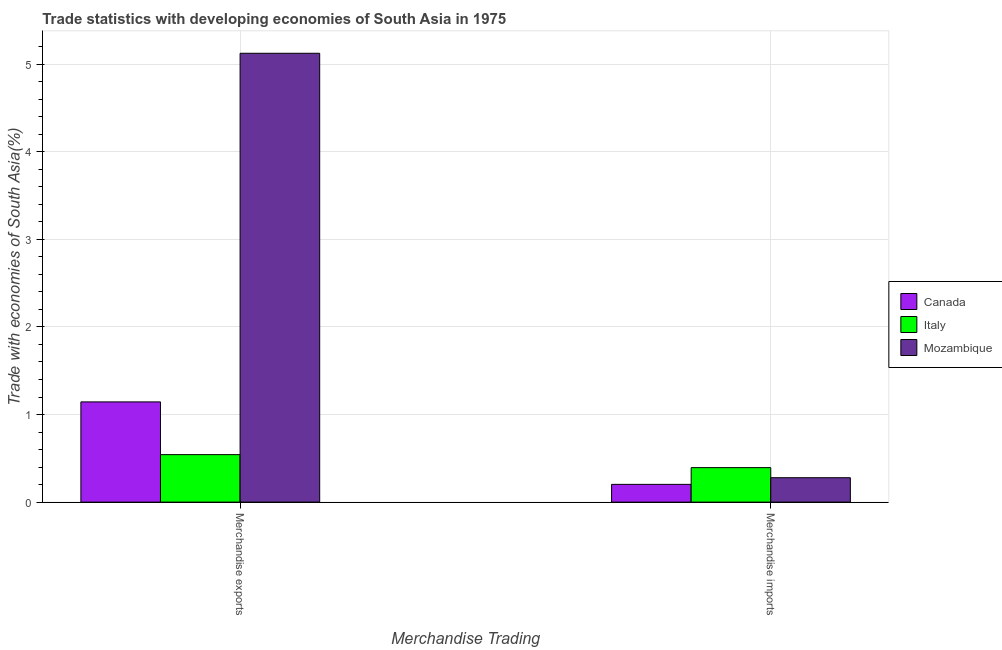How many different coloured bars are there?
Offer a terse response. 3. Are the number of bars per tick equal to the number of legend labels?
Your answer should be very brief. Yes. Are the number of bars on each tick of the X-axis equal?
Offer a terse response. Yes. How many bars are there on the 2nd tick from the left?
Keep it short and to the point. 3. How many bars are there on the 2nd tick from the right?
Offer a terse response. 3. What is the label of the 1st group of bars from the left?
Make the answer very short. Merchandise exports. What is the merchandise imports in Italy?
Your answer should be very brief. 0.39. Across all countries, what is the maximum merchandise exports?
Give a very brief answer. 5.12. Across all countries, what is the minimum merchandise exports?
Your answer should be very brief. 0.54. What is the total merchandise imports in the graph?
Keep it short and to the point. 0.88. What is the difference between the merchandise exports in Mozambique and that in Italy?
Provide a short and direct response. 4.58. What is the difference between the merchandise exports in Mozambique and the merchandise imports in Italy?
Offer a terse response. 4.73. What is the average merchandise imports per country?
Your answer should be compact. 0.29. What is the difference between the merchandise exports and merchandise imports in Canada?
Ensure brevity in your answer.  0.94. In how many countries, is the merchandise imports greater than 2.2 %?
Provide a succinct answer. 0. What is the ratio of the merchandise imports in Canada to that in Mozambique?
Give a very brief answer. 0.73. In how many countries, is the merchandise imports greater than the average merchandise imports taken over all countries?
Provide a succinct answer. 1. What does the 1st bar from the left in Merchandise exports represents?
Provide a succinct answer. Canada. What does the 3rd bar from the right in Merchandise imports represents?
Your answer should be compact. Canada. Are all the bars in the graph horizontal?
Your answer should be very brief. No. Are the values on the major ticks of Y-axis written in scientific E-notation?
Give a very brief answer. No. Does the graph contain grids?
Ensure brevity in your answer.  Yes. Where does the legend appear in the graph?
Offer a very short reply. Center right. What is the title of the graph?
Your response must be concise. Trade statistics with developing economies of South Asia in 1975. What is the label or title of the X-axis?
Provide a succinct answer. Merchandise Trading. What is the label or title of the Y-axis?
Keep it short and to the point. Trade with economies of South Asia(%). What is the Trade with economies of South Asia(%) of Canada in Merchandise exports?
Give a very brief answer. 1.14. What is the Trade with economies of South Asia(%) of Italy in Merchandise exports?
Your response must be concise. 0.54. What is the Trade with economies of South Asia(%) in Mozambique in Merchandise exports?
Offer a very short reply. 5.12. What is the Trade with economies of South Asia(%) of Canada in Merchandise imports?
Make the answer very short. 0.2. What is the Trade with economies of South Asia(%) of Italy in Merchandise imports?
Keep it short and to the point. 0.39. What is the Trade with economies of South Asia(%) of Mozambique in Merchandise imports?
Ensure brevity in your answer.  0.28. Across all Merchandise Trading, what is the maximum Trade with economies of South Asia(%) in Canada?
Your response must be concise. 1.14. Across all Merchandise Trading, what is the maximum Trade with economies of South Asia(%) in Italy?
Offer a terse response. 0.54. Across all Merchandise Trading, what is the maximum Trade with economies of South Asia(%) of Mozambique?
Your answer should be compact. 5.12. Across all Merchandise Trading, what is the minimum Trade with economies of South Asia(%) in Canada?
Ensure brevity in your answer.  0.2. Across all Merchandise Trading, what is the minimum Trade with economies of South Asia(%) in Italy?
Provide a succinct answer. 0.39. Across all Merchandise Trading, what is the minimum Trade with economies of South Asia(%) in Mozambique?
Ensure brevity in your answer.  0.28. What is the total Trade with economies of South Asia(%) in Canada in the graph?
Make the answer very short. 1.35. What is the total Trade with economies of South Asia(%) in Italy in the graph?
Your answer should be very brief. 0.94. What is the total Trade with economies of South Asia(%) of Mozambique in the graph?
Offer a terse response. 5.4. What is the difference between the Trade with economies of South Asia(%) in Canada in Merchandise exports and that in Merchandise imports?
Provide a short and direct response. 0.94. What is the difference between the Trade with economies of South Asia(%) of Italy in Merchandise exports and that in Merchandise imports?
Your answer should be compact. 0.15. What is the difference between the Trade with economies of South Asia(%) of Mozambique in Merchandise exports and that in Merchandise imports?
Your answer should be compact. 4.85. What is the difference between the Trade with economies of South Asia(%) of Canada in Merchandise exports and the Trade with economies of South Asia(%) of Italy in Merchandise imports?
Offer a terse response. 0.75. What is the difference between the Trade with economies of South Asia(%) of Canada in Merchandise exports and the Trade with economies of South Asia(%) of Mozambique in Merchandise imports?
Ensure brevity in your answer.  0.87. What is the difference between the Trade with economies of South Asia(%) in Italy in Merchandise exports and the Trade with economies of South Asia(%) in Mozambique in Merchandise imports?
Your answer should be very brief. 0.26. What is the average Trade with economies of South Asia(%) of Canada per Merchandise Trading?
Your answer should be compact. 0.67. What is the average Trade with economies of South Asia(%) in Italy per Merchandise Trading?
Your answer should be compact. 0.47. What is the average Trade with economies of South Asia(%) in Mozambique per Merchandise Trading?
Your answer should be compact. 2.7. What is the difference between the Trade with economies of South Asia(%) of Canada and Trade with economies of South Asia(%) of Italy in Merchandise exports?
Your answer should be compact. 0.6. What is the difference between the Trade with economies of South Asia(%) of Canada and Trade with economies of South Asia(%) of Mozambique in Merchandise exports?
Your response must be concise. -3.98. What is the difference between the Trade with economies of South Asia(%) in Italy and Trade with economies of South Asia(%) in Mozambique in Merchandise exports?
Your answer should be compact. -4.58. What is the difference between the Trade with economies of South Asia(%) in Canada and Trade with economies of South Asia(%) in Italy in Merchandise imports?
Your answer should be compact. -0.19. What is the difference between the Trade with economies of South Asia(%) of Canada and Trade with economies of South Asia(%) of Mozambique in Merchandise imports?
Your answer should be compact. -0.08. What is the difference between the Trade with economies of South Asia(%) of Italy and Trade with economies of South Asia(%) of Mozambique in Merchandise imports?
Keep it short and to the point. 0.12. What is the ratio of the Trade with economies of South Asia(%) of Canada in Merchandise exports to that in Merchandise imports?
Your response must be concise. 5.64. What is the ratio of the Trade with economies of South Asia(%) of Italy in Merchandise exports to that in Merchandise imports?
Offer a terse response. 1.38. What is the ratio of the Trade with economies of South Asia(%) in Mozambique in Merchandise exports to that in Merchandise imports?
Your answer should be compact. 18.38. What is the difference between the highest and the second highest Trade with economies of South Asia(%) of Canada?
Your answer should be compact. 0.94. What is the difference between the highest and the second highest Trade with economies of South Asia(%) in Italy?
Offer a terse response. 0.15. What is the difference between the highest and the second highest Trade with economies of South Asia(%) in Mozambique?
Offer a very short reply. 4.85. What is the difference between the highest and the lowest Trade with economies of South Asia(%) in Canada?
Keep it short and to the point. 0.94. What is the difference between the highest and the lowest Trade with economies of South Asia(%) of Italy?
Keep it short and to the point. 0.15. What is the difference between the highest and the lowest Trade with economies of South Asia(%) in Mozambique?
Your answer should be compact. 4.85. 